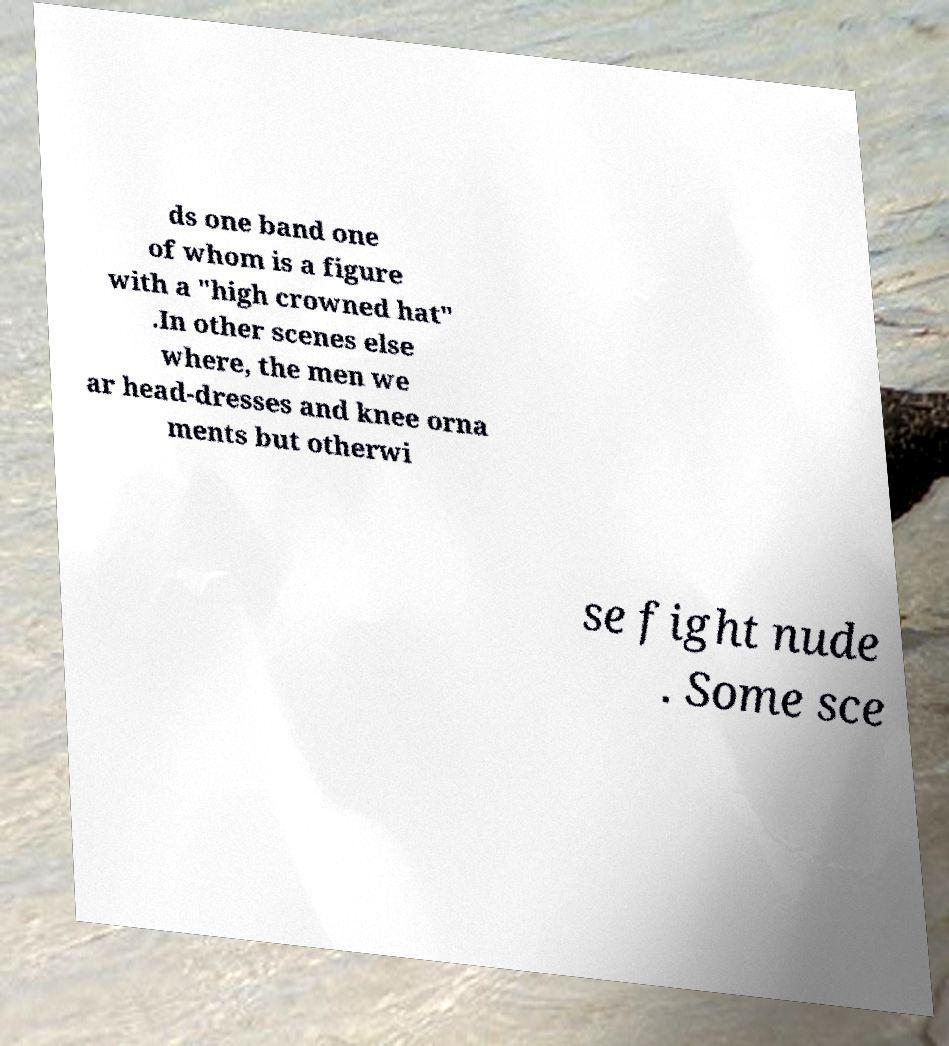Could you extract and type out the text from this image? ds one band one of whom is a figure with a "high crowned hat" .In other scenes else where, the men we ar head-dresses and knee orna ments but otherwi se fight nude . Some sce 